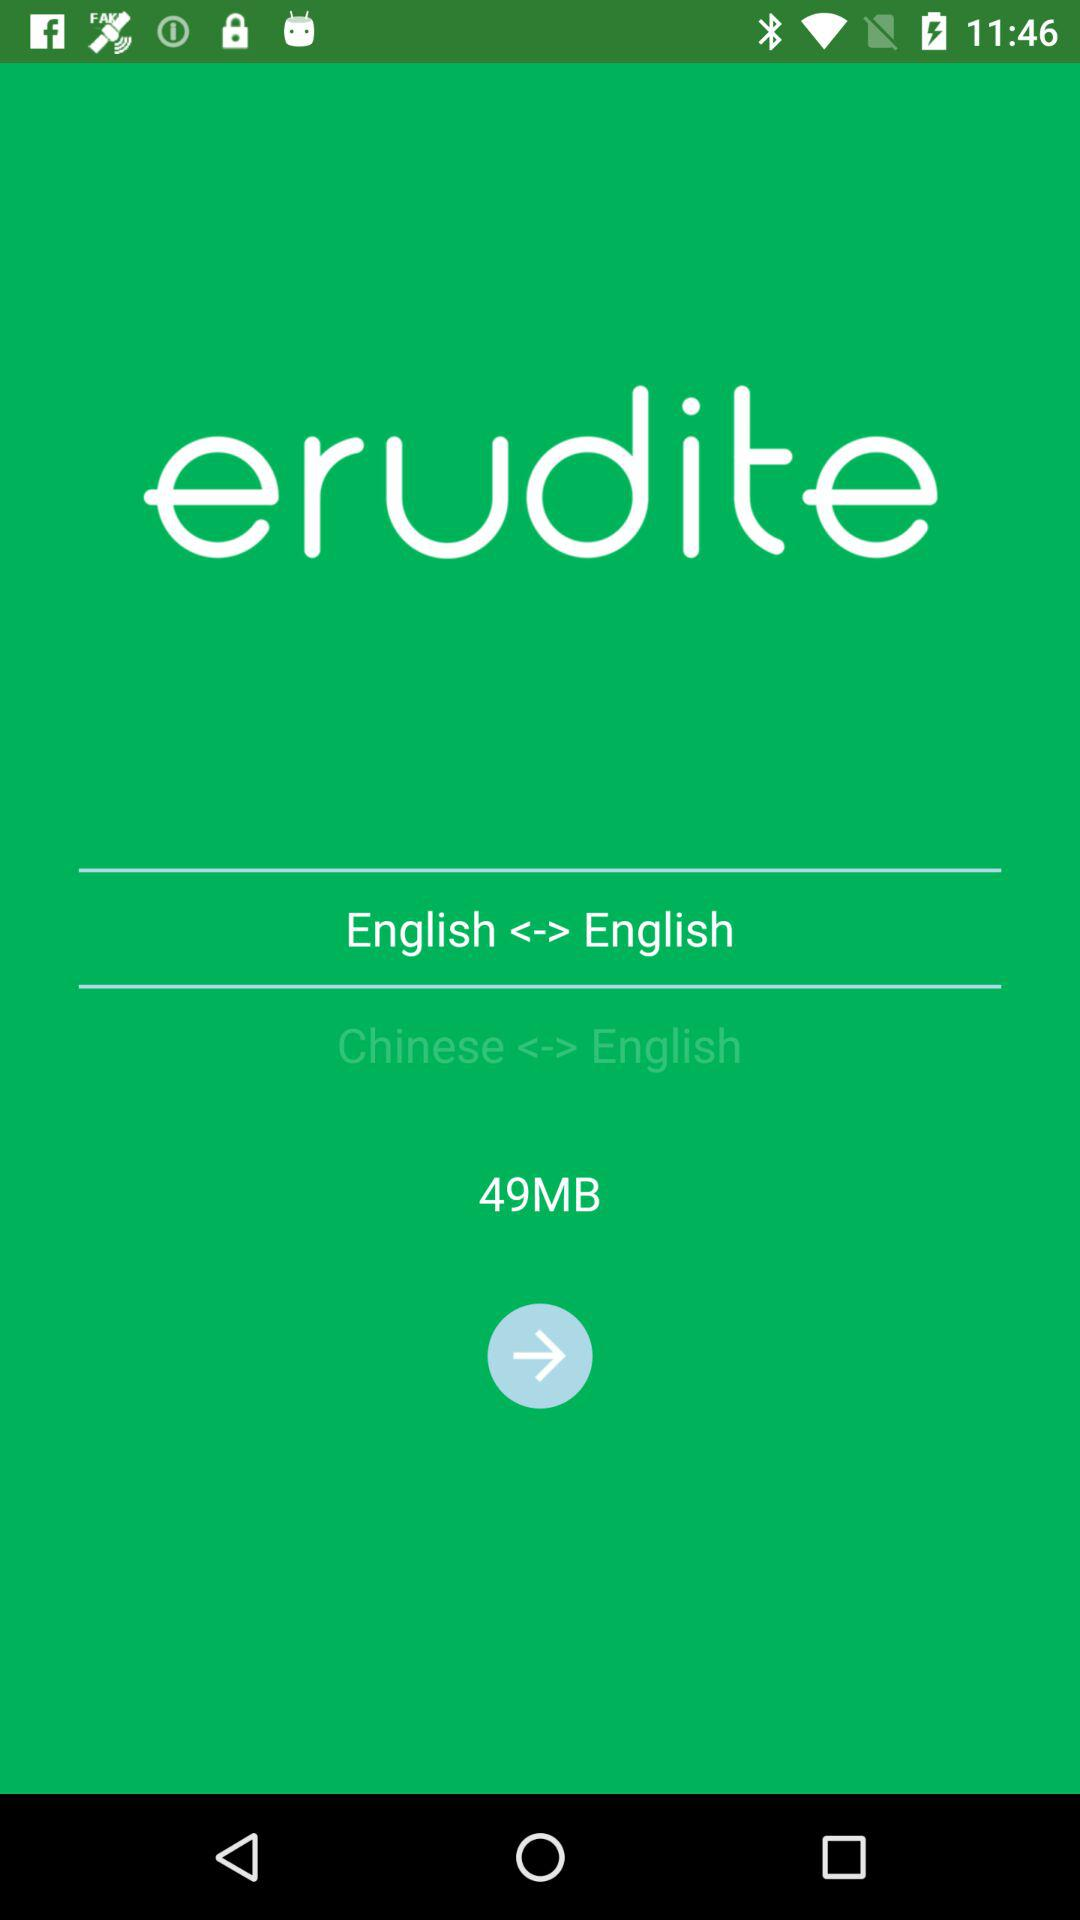What is the size of the file that the user is downloading?
Answer the question using a single word or phrase. 49MB 